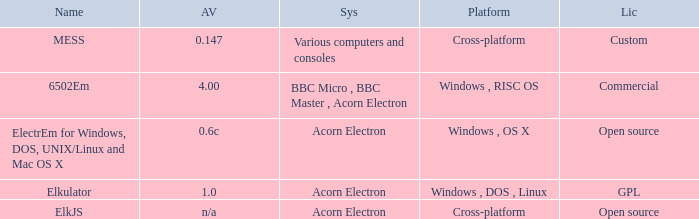What is the appellation of the platform used for assorted computers and consoles? Cross-platform. 